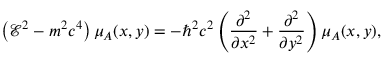<formula> <loc_0><loc_0><loc_500><loc_500>\left ( \mathcal { E } ^ { 2 } - m ^ { 2 } c ^ { 4 } \right ) \mu _ { A } ( x , y ) = - \hbar { ^ } { 2 } c ^ { 2 } \left ( \frac { \partial ^ { 2 } } { \partial x ^ { 2 } } + \frac { \partial ^ { 2 } } { \partial y ^ { 2 } } \right ) \mu _ { A } ( x , y ) ,</formula> 